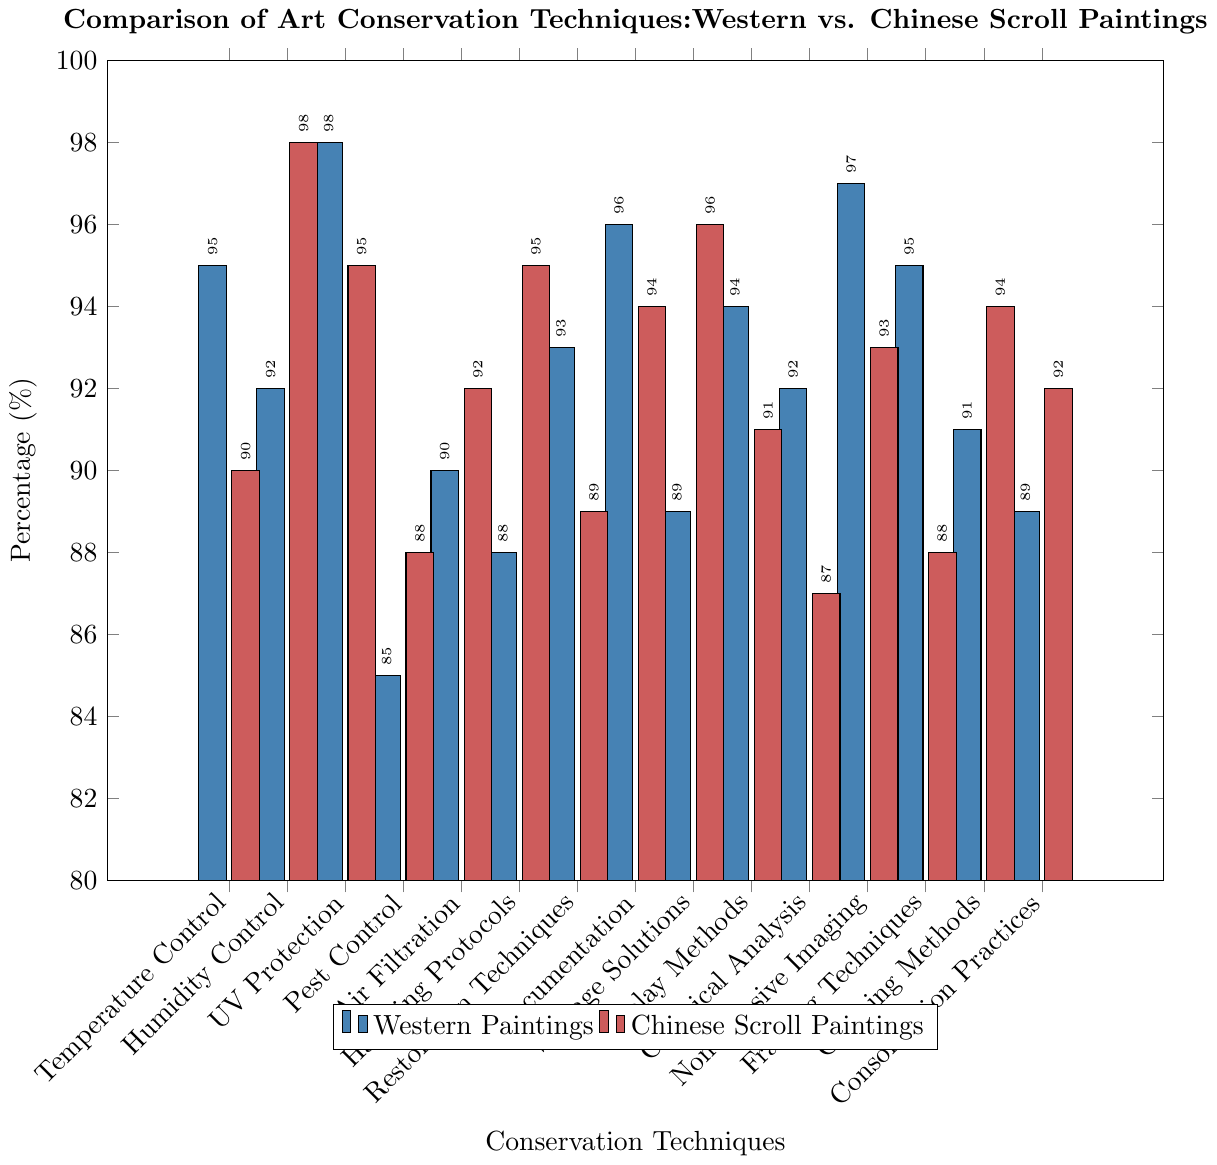Which conservation technique shows the highest percentage for Western paintings? The bar representing Non-invasive Imaging for Western paintings is the tallest among all bars in the Western Paintings category.
Answer: Non-invasive Imaging Which conservation technique shows the smallest percentage for Chinese Scroll Paintings? The bar representing Chemical Analysis for Chinese Scroll Paintings is the shortest among all bars in the Chinese Scroll Paintings category.
Answer: Chemical Analysis By how much does UV Protection for Western paintings exceed that for Chinese Scroll paintings? The percentage for UV Protection in Western paintings is 98%, and for Chinese Scroll paintings, it is 95%. Subtracting 95% from 98% gives 3%.
Answer: 3% Which conservation techniques are equally applied to both Western and Chinese Scroll paintings? The bars for Air Filtration show equal heights for both Western and Chinese Scroll paintings, both at 92%.
Answer: Air Filtration What is the difference in percentage between the highest and lowest conservation technique used for Chinese Scroll paintings? The highest percentage for Chinese Scroll paintings is Humidity Control at 98%, and the lowest is Chemical Analysis at 87%. Subtracting 87% from 98% gives 11%.
Answer: 11% Which conservation techniques have a higher percentage for Chinese Scroll paintings than Western paintings? By comparing the heights of the bars, Chinese Scroll paintings have higher percentages in Humidity Control (98% vs 92%), Handling Protocols (95% vs 88%), Storage Solutions (96% vs 89%), Cleaning Methods (94% vs 91%), and Consolidation Practices (92% vs 89%).
Answer: Humidity Control, Handling Protocols, Storage Solutions, Cleaning Methods, Consolidation Practices Which technique has the biggest percentage gap between Western and Chinese Scroll paintings? The biggest gap is between Handling Protocols, where Chinese Scroll paintings have 95% and Western paintings have 88%. The difference is 7%.
Answer: Handling Protocols What is the average percentage of the Display Methods for both Western and Chinese Scroll paintings? The percentages for Display Methods are 94% for Western paintings and 91% for Chinese Scroll paintings. The average is calculated as (94 + 91) / 2 = 92.5%.
Answer: 92.5% What are the top three conservation techniques for Western paintings based on percentage? The top three techniques for Western paintings based on the highest percentages are Non-invasive Imaging (97%), UV Protection (98%), and Documentation (96%).
Answer: Non-invasive Imaging, UV Protection, Documentation 